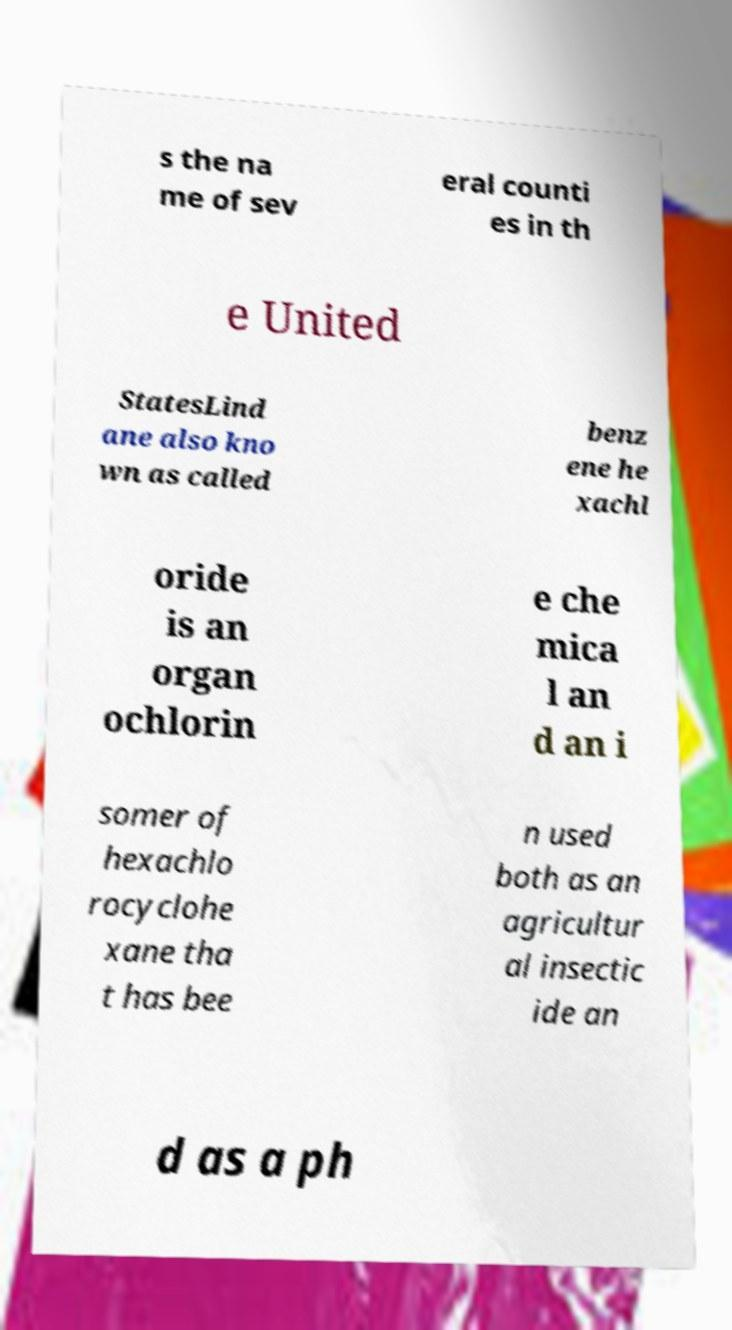I need the written content from this picture converted into text. Can you do that? s the na me of sev eral counti es in th e United StatesLind ane also kno wn as called benz ene he xachl oride is an organ ochlorin e che mica l an d an i somer of hexachlo rocyclohe xane tha t has bee n used both as an agricultur al insectic ide an d as a ph 